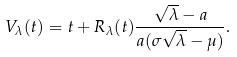<formula> <loc_0><loc_0><loc_500><loc_500>V _ { \lambda } ( t ) = t + R _ { \lambda } ( t ) \frac { \sqrt { \lambda } - a } { a ( \sigma \sqrt { \lambda } - \mu ) } .</formula> 